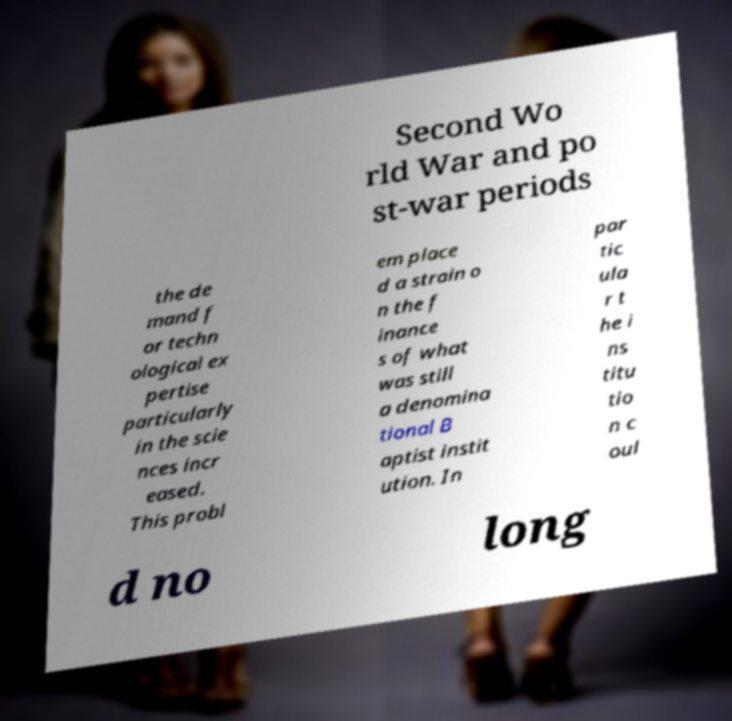I need the written content from this picture converted into text. Can you do that? Second Wo rld War and po st-war periods the de mand f or techn ological ex pertise particularly in the scie nces incr eased. This probl em place d a strain o n the f inance s of what was still a denomina tional B aptist instit ution. In par tic ula r t he i ns titu tio n c oul d no long 